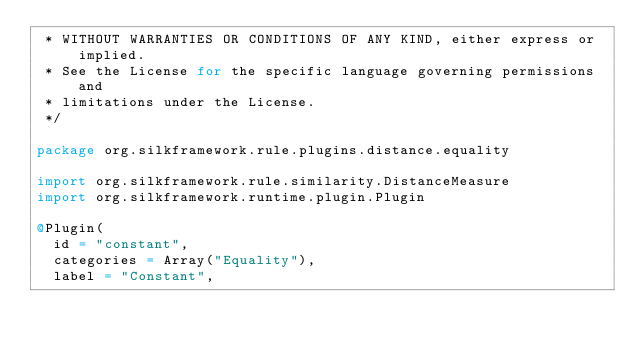Convert code to text. <code><loc_0><loc_0><loc_500><loc_500><_Scala_> * WITHOUT WARRANTIES OR CONDITIONS OF ANY KIND, either express or implied.
 * See the License for the specific language governing permissions and
 * limitations under the License.
 */

package org.silkframework.rule.plugins.distance.equality

import org.silkframework.rule.similarity.DistanceMeasure
import org.silkframework.runtime.plugin.Plugin

@Plugin(
  id = "constant",
  categories = Array("Equality"),
  label = "Constant",</code> 